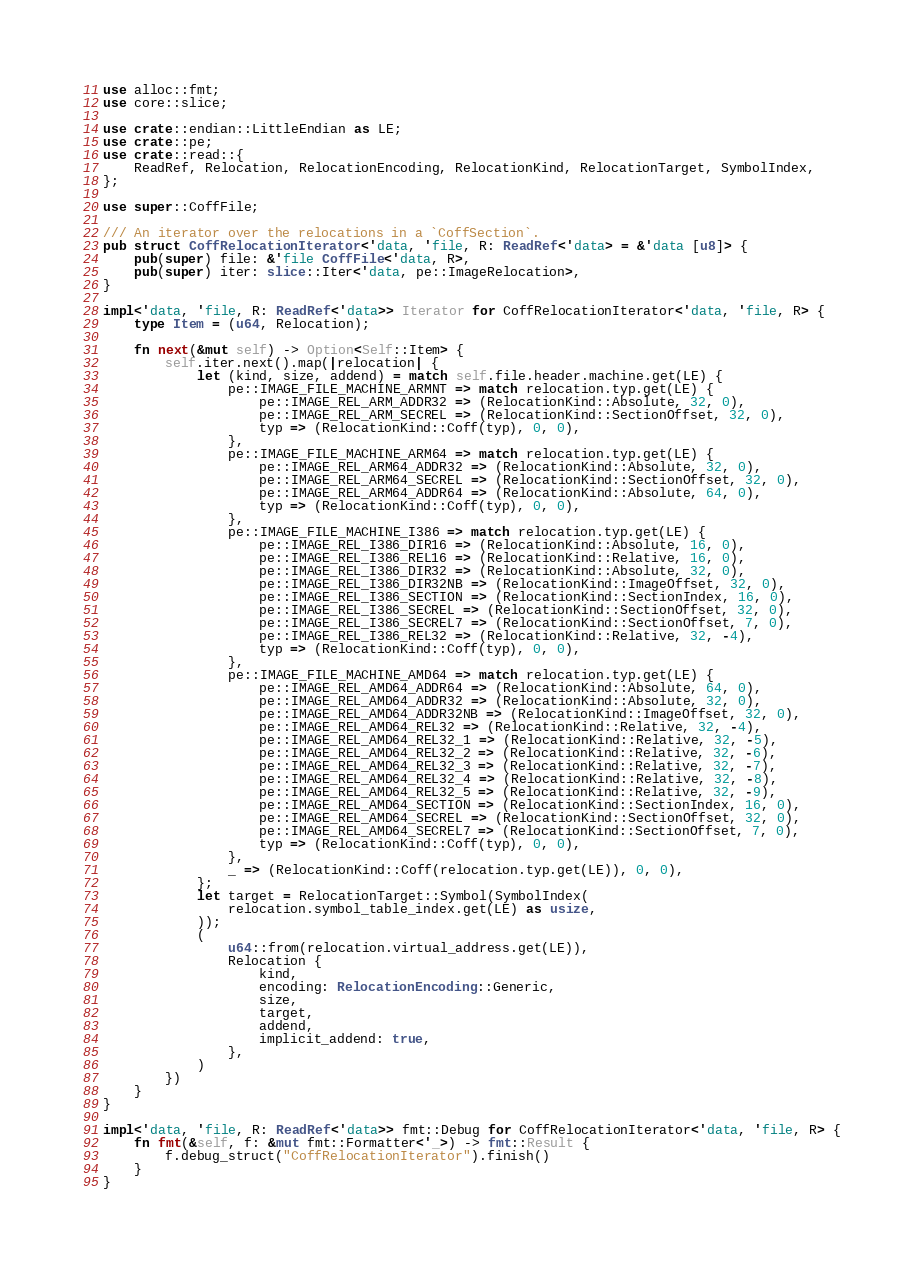<code> <loc_0><loc_0><loc_500><loc_500><_Rust_>use alloc::fmt;
use core::slice;

use crate::endian::LittleEndian as LE;
use crate::pe;
use crate::read::{
    ReadRef, Relocation, RelocationEncoding, RelocationKind, RelocationTarget, SymbolIndex,
};

use super::CoffFile;

/// An iterator over the relocations in a `CoffSection`.
pub struct CoffRelocationIterator<'data, 'file, R: ReadRef<'data> = &'data [u8]> {
    pub(super) file: &'file CoffFile<'data, R>,
    pub(super) iter: slice::Iter<'data, pe::ImageRelocation>,
}

impl<'data, 'file, R: ReadRef<'data>> Iterator for CoffRelocationIterator<'data, 'file, R> {
    type Item = (u64, Relocation);

    fn next(&mut self) -> Option<Self::Item> {
        self.iter.next().map(|relocation| {
            let (kind, size, addend) = match self.file.header.machine.get(LE) {
                pe::IMAGE_FILE_MACHINE_ARMNT => match relocation.typ.get(LE) {
                    pe::IMAGE_REL_ARM_ADDR32 => (RelocationKind::Absolute, 32, 0),
                    pe::IMAGE_REL_ARM_SECREL => (RelocationKind::SectionOffset, 32, 0),
                    typ => (RelocationKind::Coff(typ), 0, 0),
                },
                pe::IMAGE_FILE_MACHINE_ARM64 => match relocation.typ.get(LE) {
                    pe::IMAGE_REL_ARM64_ADDR32 => (RelocationKind::Absolute, 32, 0),
                    pe::IMAGE_REL_ARM64_SECREL => (RelocationKind::SectionOffset, 32, 0),
                    pe::IMAGE_REL_ARM64_ADDR64 => (RelocationKind::Absolute, 64, 0),
                    typ => (RelocationKind::Coff(typ), 0, 0),
                },
                pe::IMAGE_FILE_MACHINE_I386 => match relocation.typ.get(LE) {
                    pe::IMAGE_REL_I386_DIR16 => (RelocationKind::Absolute, 16, 0),
                    pe::IMAGE_REL_I386_REL16 => (RelocationKind::Relative, 16, 0),
                    pe::IMAGE_REL_I386_DIR32 => (RelocationKind::Absolute, 32, 0),
                    pe::IMAGE_REL_I386_DIR32NB => (RelocationKind::ImageOffset, 32, 0),
                    pe::IMAGE_REL_I386_SECTION => (RelocationKind::SectionIndex, 16, 0),
                    pe::IMAGE_REL_I386_SECREL => (RelocationKind::SectionOffset, 32, 0),
                    pe::IMAGE_REL_I386_SECREL7 => (RelocationKind::SectionOffset, 7, 0),
                    pe::IMAGE_REL_I386_REL32 => (RelocationKind::Relative, 32, -4),
                    typ => (RelocationKind::Coff(typ), 0, 0),
                },
                pe::IMAGE_FILE_MACHINE_AMD64 => match relocation.typ.get(LE) {
                    pe::IMAGE_REL_AMD64_ADDR64 => (RelocationKind::Absolute, 64, 0),
                    pe::IMAGE_REL_AMD64_ADDR32 => (RelocationKind::Absolute, 32, 0),
                    pe::IMAGE_REL_AMD64_ADDR32NB => (RelocationKind::ImageOffset, 32, 0),
                    pe::IMAGE_REL_AMD64_REL32 => (RelocationKind::Relative, 32, -4),
                    pe::IMAGE_REL_AMD64_REL32_1 => (RelocationKind::Relative, 32, -5),
                    pe::IMAGE_REL_AMD64_REL32_2 => (RelocationKind::Relative, 32, -6),
                    pe::IMAGE_REL_AMD64_REL32_3 => (RelocationKind::Relative, 32, -7),
                    pe::IMAGE_REL_AMD64_REL32_4 => (RelocationKind::Relative, 32, -8),
                    pe::IMAGE_REL_AMD64_REL32_5 => (RelocationKind::Relative, 32, -9),
                    pe::IMAGE_REL_AMD64_SECTION => (RelocationKind::SectionIndex, 16, 0),
                    pe::IMAGE_REL_AMD64_SECREL => (RelocationKind::SectionOffset, 32, 0),
                    pe::IMAGE_REL_AMD64_SECREL7 => (RelocationKind::SectionOffset, 7, 0),
                    typ => (RelocationKind::Coff(typ), 0, 0),
                },
                _ => (RelocationKind::Coff(relocation.typ.get(LE)), 0, 0),
            };
            let target = RelocationTarget::Symbol(SymbolIndex(
                relocation.symbol_table_index.get(LE) as usize,
            ));
            (
                u64::from(relocation.virtual_address.get(LE)),
                Relocation {
                    kind,
                    encoding: RelocationEncoding::Generic,
                    size,
                    target,
                    addend,
                    implicit_addend: true,
                },
            )
        })
    }
}

impl<'data, 'file, R: ReadRef<'data>> fmt::Debug for CoffRelocationIterator<'data, 'file, R> {
    fn fmt(&self, f: &mut fmt::Formatter<'_>) -> fmt::Result {
        f.debug_struct("CoffRelocationIterator").finish()
    }
}
</code> 